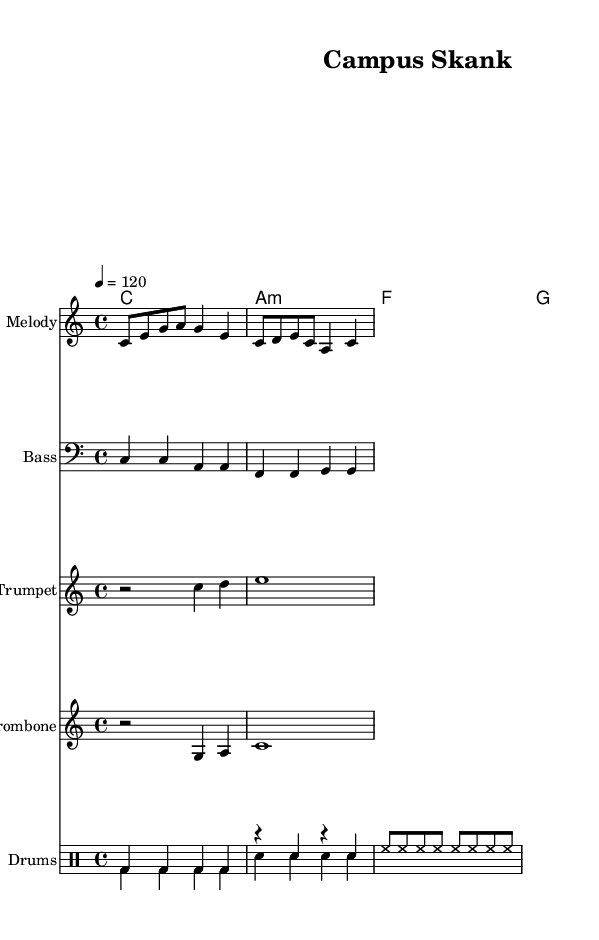What is the key signature of this music? The key signature is C major, which has no sharps or flats indicated at the beginning of the staff.
Answer: C major What is the time signature of this piece? The time signature is indicated as 4/4, meaning there are four beats in each measure and the quarter note gets one beat.
Answer: 4/4 What is the tempo marking for this piece? The tempo is set at a speed of 120 beats per minute, indicated by the markings at the beginning of the global context.
Answer: 120 Which instruments are used in this score? The score includes Melody, Bass, Trumpet, Trombone, and Drums, as indicated in the various staff labels.
Answer: Melody, Bass, Trumpet, Trombone, Drums How many measures are in the melody section? The melody section contains 2 complete measures as noted by the bar lines that divide the music into sections.
Answer: 2 What type of rhythm is predominant in the drum part? The drum part shows a steady, repetitive rhythm, mainly using bass drums and snare, which is common in reggae music for a driving beat.
Answer: Repetitive rhythm What characteristic of reggae is reflected in the chords used? The chords used in a reggae style typically include major and minor chords built on the tonic, subdominant, and dominant, which are common in ska-influenced reggae.
Answer: Major and minor chords 